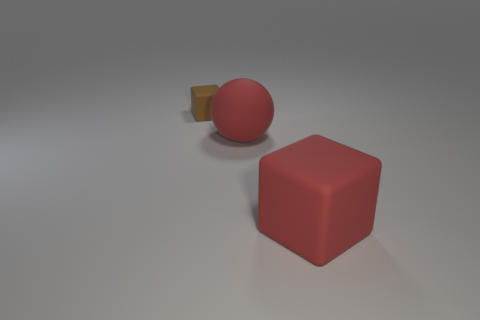Add 2 large metallic balls. How many objects exist? 5 Subtract all blocks. How many objects are left? 1 Add 3 cyan shiny cylinders. How many cyan shiny cylinders exist? 3 Subtract 0 blue cylinders. How many objects are left? 3 Subtract all red spheres. Subtract all small brown things. How many objects are left? 1 Add 2 large red rubber blocks. How many large red rubber blocks are left? 3 